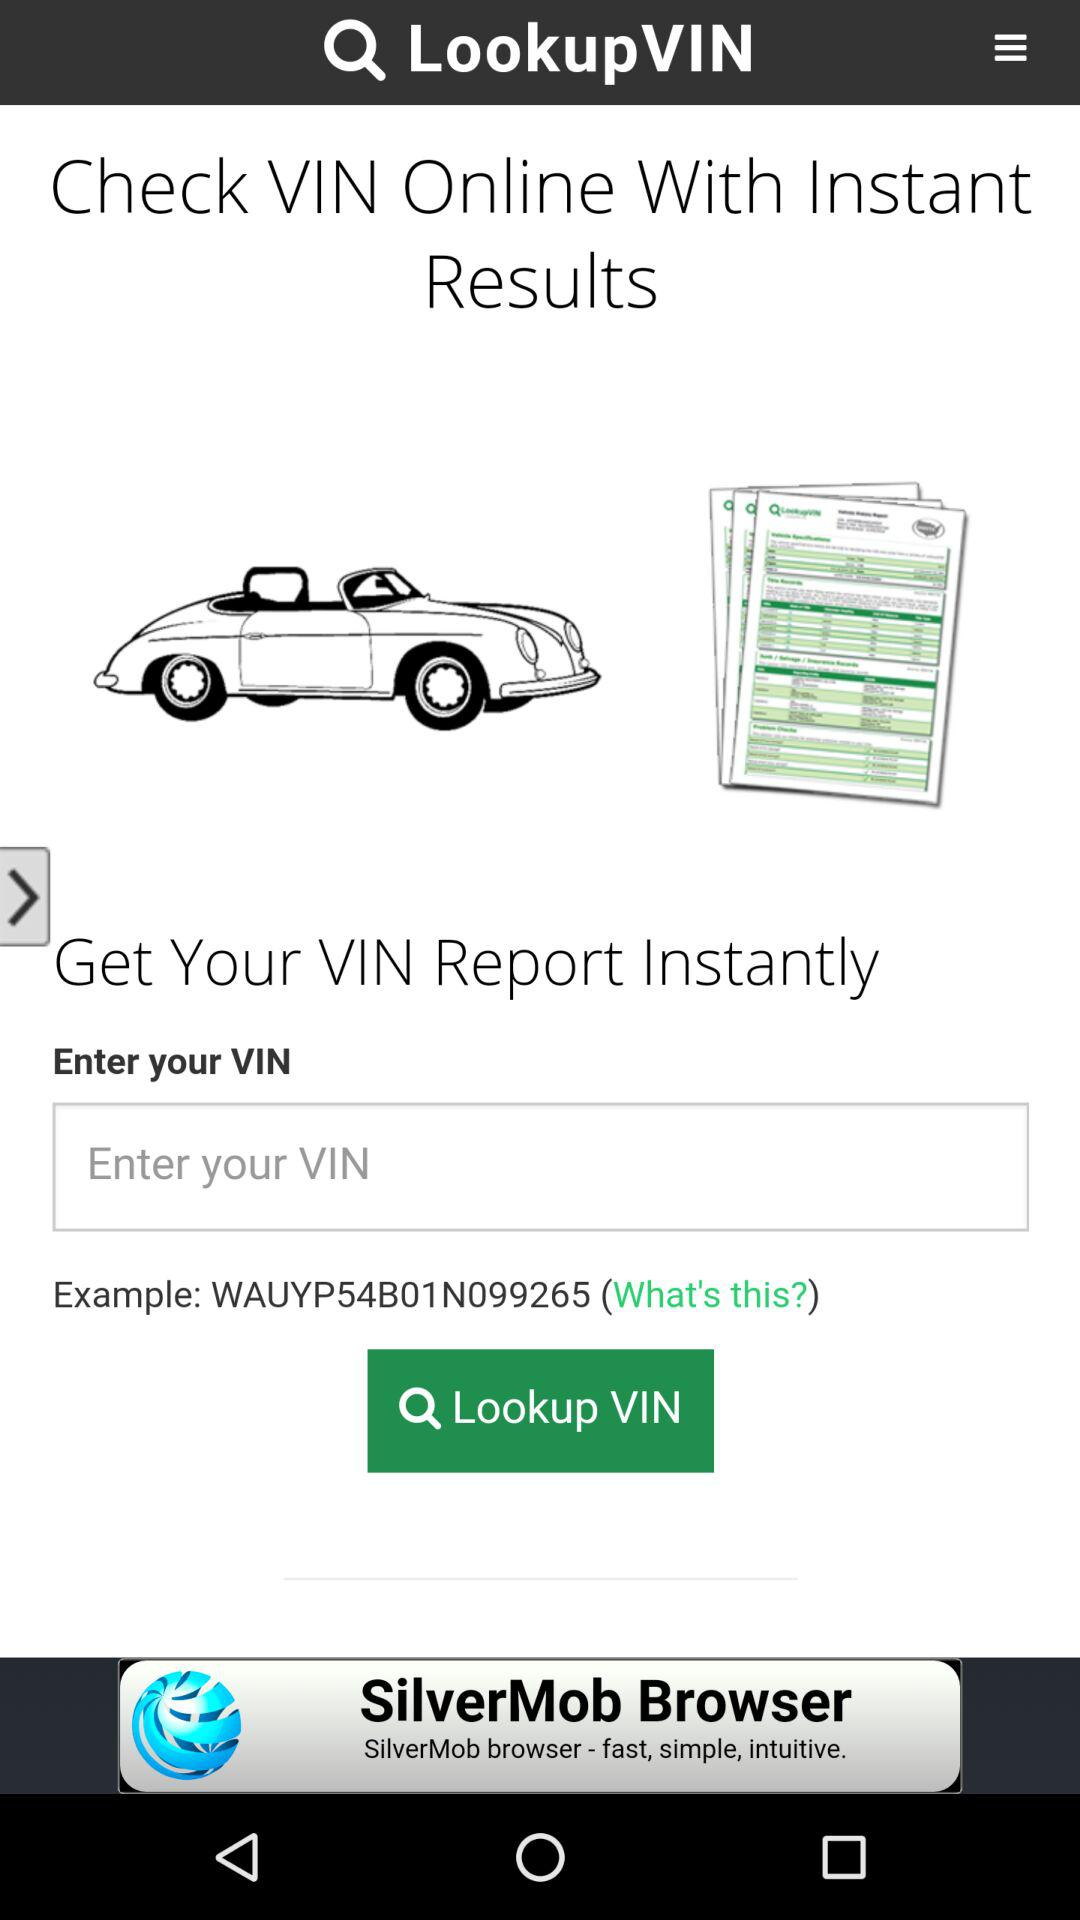What does a VIN look like? A VIN looks like "WAUYP54B01N099265". 